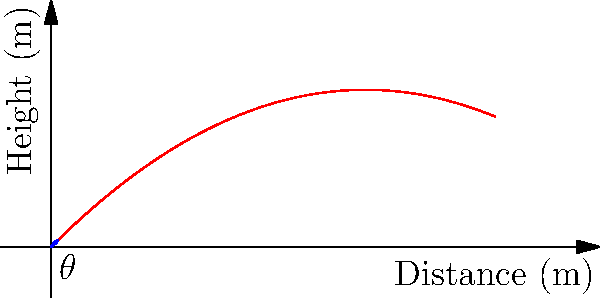As a cricket bowler, you're aiming to optimize your ball trajectory. Given an initial velocity of 30 m/s and a release angle of 45 degrees, calculate the maximum height reached by the cricket ball. Assume air resistance is negligible and use g = 9.8 m/s². To find the maximum height of the cricket ball's trajectory, we'll follow these steps:

1) The vertical component of the initial velocity is given by:
   $v_{0y} = v_0 \sin(\theta) = 30 \sin(45°) = 30 \cdot \frac{\sqrt{2}}{2} \approx 21.21$ m/s

2) The time to reach the maximum height is when the vertical velocity becomes zero:
   $v_y = v_{0y} - gt = 0$
   $t_{max} = \frac{v_{0y}}{g} = \frac{21.21}{9.8} \approx 2.16$ seconds

3) The maximum height can be calculated using the equation:
   $h_{max} = v_{0y}t - \frac{1}{2}gt^2$

4) Substituting the values:
   $h_{max} = 21.21 \cdot 2.16 - \frac{1}{2} \cdot 9.8 \cdot 2.16^2$
   $h_{max} = 45.81 - 22.91 = 22.90$ meters

Therefore, the maximum height reached by the cricket ball is approximately 22.90 meters.
Answer: 22.90 meters 